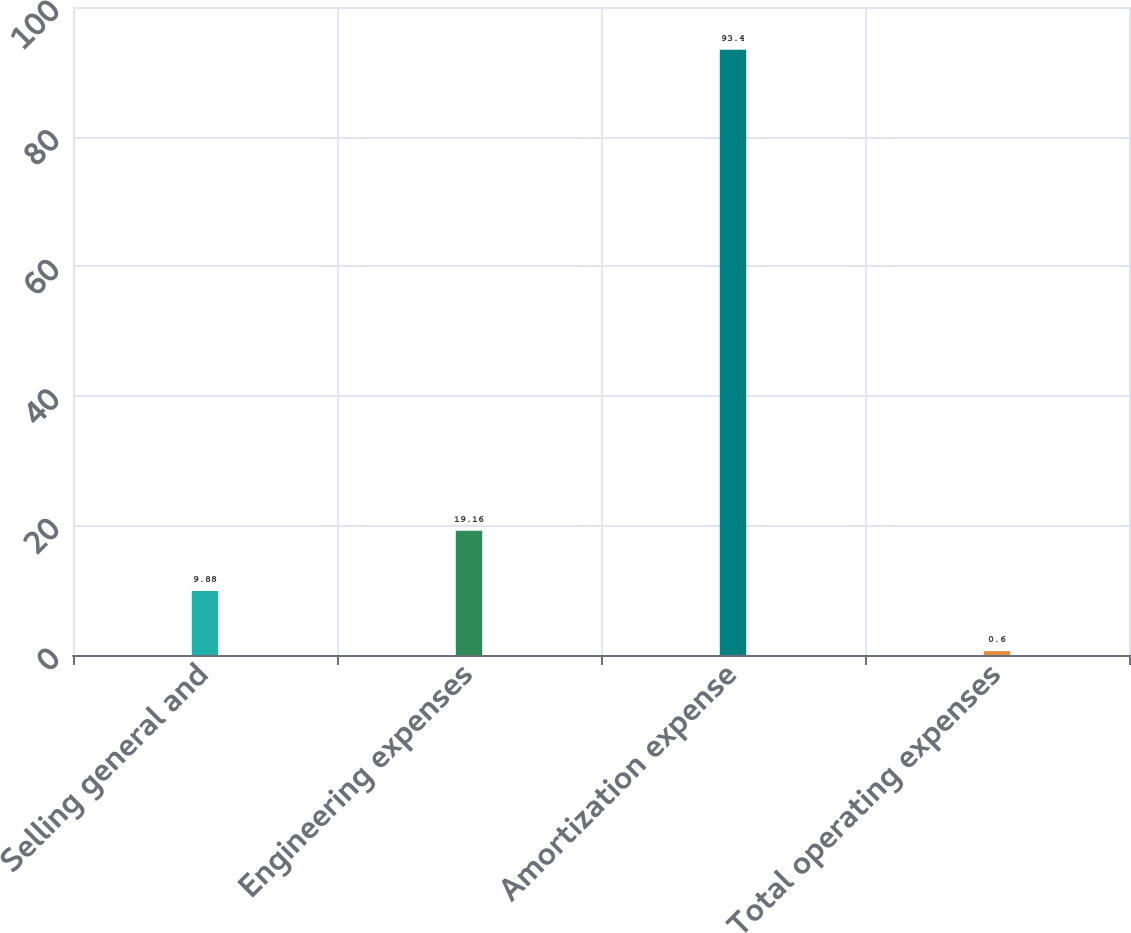Convert chart. <chart><loc_0><loc_0><loc_500><loc_500><bar_chart><fcel>Selling general and<fcel>Engineering expenses<fcel>Amortization expense<fcel>Total operating expenses<nl><fcel>9.88<fcel>19.16<fcel>93.4<fcel>0.6<nl></chart> 